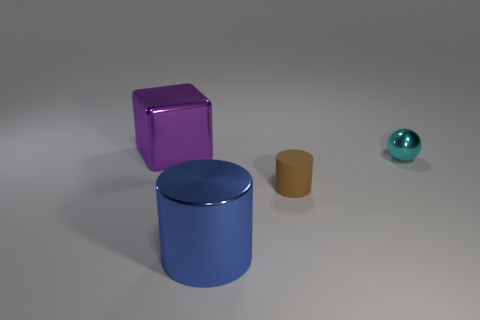Do the metallic object left of the blue object and the cylinder that is on the right side of the big blue shiny cylinder have the same size?
Make the answer very short. No. How many cylinders are either cyan rubber objects or small brown matte things?
Give a very brief answer. 1. How many metal objects are either cylinders or big things?
Ensure brevity in your answer.  2. What is the size of the shiny thing that is the same shape as the matte object?
Your answer should be compact. Large. Is there any other thing that is the same size as the metal sphere?
Offer a terse response. Yes. Is the size of the rubber object the same as the metal object behind the cyan sphere?
Keep it short and to the point. No. There is a metallic object in front of the cyan metallic ball; what shape is it?
Give a very brief answer. Cylinder. What color is the big metallic object that is right of the large object behind the tiny brown matte thing?
Provide a short and direct response. Blue. What is the color of the large thing that is the same shape as the small brown object?
Offer a very short reply. Blue. Do the matte cylinder and the big object that is in front of the purple metallic thing have the same color?
Offer a very short reply. No. 